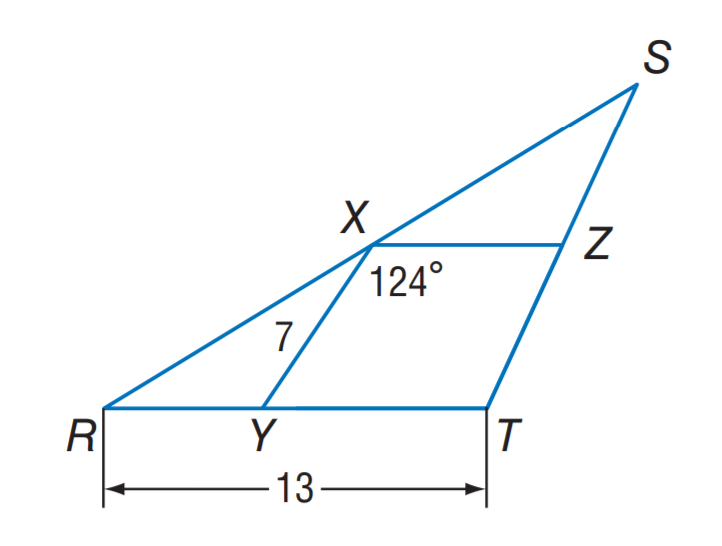Answer the mathemtical geometry problem and directly provide the correct option letter.
Question: X Y and X Z are midsegments of \triangle R S T. Find m \angle R Y X.
Choices: A: 110 B: 124 C: 126 D: 134 B 